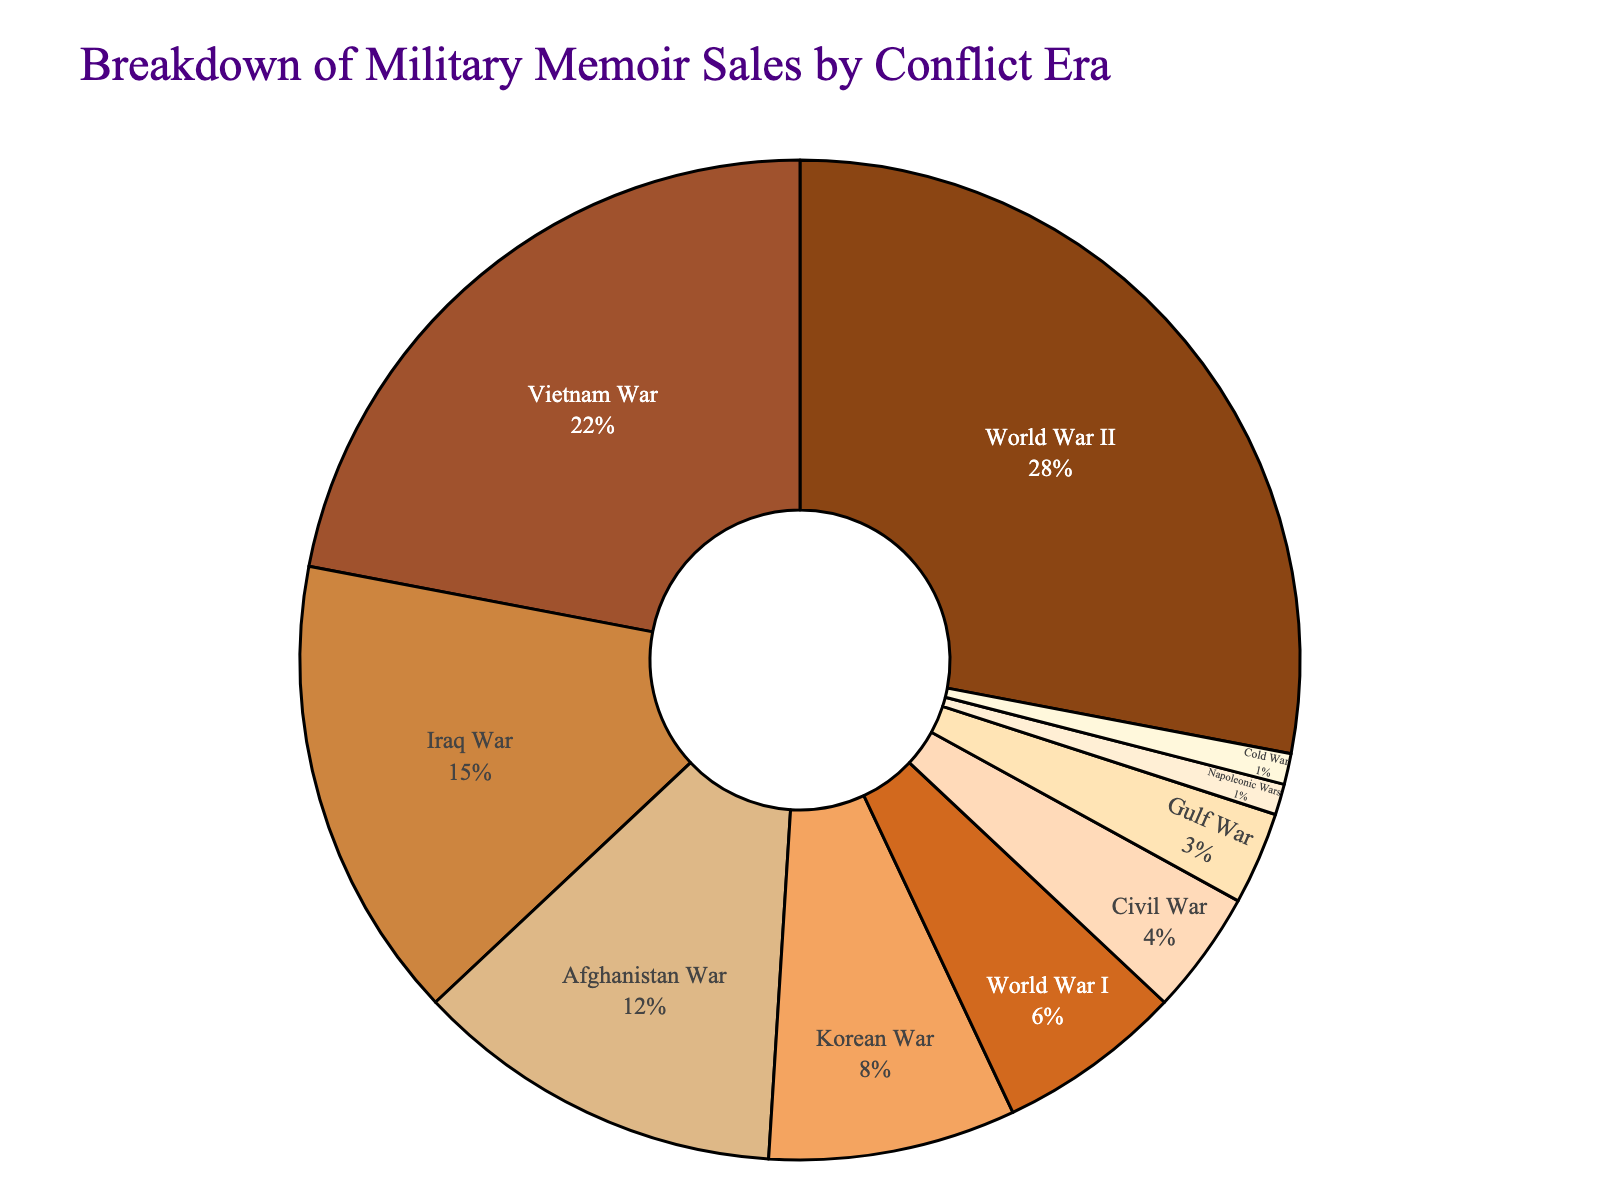What conflict era has the highest percentage of military memoir sales? The pie chart has segments labeled with both the percentage and conflict era. The largest segment, which has the highest percentage, is labeled "World War II" with 28%.
Answer: World War II Which conflict era has a lower percentage of military memoir sales, the Civil War or the Gulf War? Compare the percentage values for the Civil War and the Gulf War. The Civil War has 4% while the Gulf War has 3%. 3% is lower than 4%.
Answer: Gulf War What is the combined percentage of military memoir sales for the Iraq War and Afghanistan War? Sum the percentages of the Iraq War and Afghanistan War segments. The Iraq War has 15% and the Afghanistan War has 12%. The combined percentage is 15% + 12%.
Answer: 27% Is the total percentage of memoir sales for wars before the 20th century higher or lower than those from the Korean War? To answer this, add the percentages for pre-20th century wars (Civil War: 4%, Napoleonic Wars: 1%) and compare this to the Korean War (8%). The total is 4% + 1% = 5%, which is lower than 8%.
Answer: Lower What era accounts for less than 5% but more than 2% of the memoir sales? Look for an era with a percentage that fits in the range (2%, 5%). The Gulf War with 3% fits this requirement.
Answer: Gulf War What is the difference in percentage points between memoir sales for the Vietnam War and World War I? The percentages for the Vietnam War and World War I are 22% and 6%, respectively. The difference is 22% - 6%.
Answer: 16% Which conflict era sales combined are equal to the World War II memoir sales? Combine sales of different eras to find the ones that sum to 28%. The Afghanistan War (12%) and Vietnam War (22%) sum to 12% + 22% = 34%, which is too high. Try another combination. The Civil War (4%), World War I (6%), Korean War (8%), and Gulf War (3%) sum up to 4% + 6% + 8% + 3% = 21%, also not matching. The Iraq War (15%) and Afghanistan War (12%) sum to 15% + 12% = 27%, just off by 1%. No combination exactly matches 28%. Thus, there is no exact combination in the given data.
Answer: No exact match What is the visually smallest segment on the pie chart? The segment with the smallest percentage will be the smallest visual segment. The Napoleonic Wars and Cold War each have the smallest value, which is 1%.
Answer: Napoleonic Wars, Cold War How many eras have a contribution of 10% or more? Count the sections with percentages 10% or higher. World War II (28%), Vietnam War (22%), and Iraq War (15%) each contribute 10% or more. There are 3 such eras.
Answer: 3 